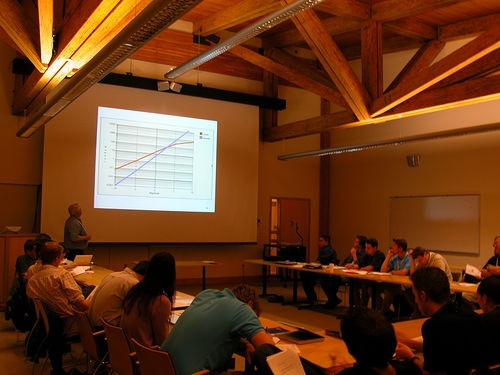Describe the objects in this image and their specific colors. I can see tv in maroon, white, lightblue, brown, and darkgray tones, people in maroon, black, and brown tones, people in maroon, black, and darkgreen tones, people in maroon, black, and brown tones, and people in maroon, black, and brown tones in this image. 